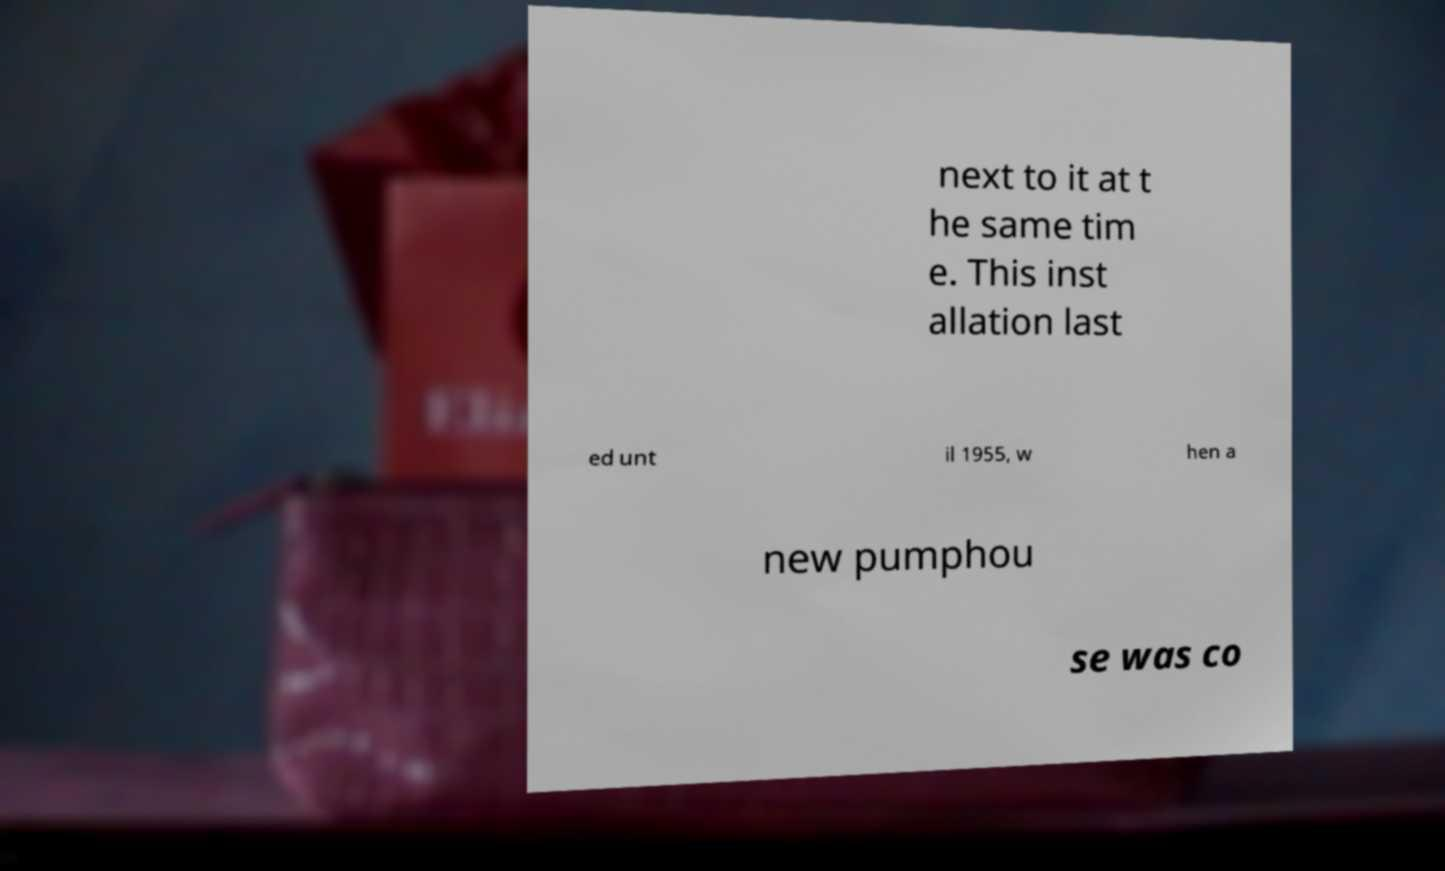Can you read and provide the text displayed in the image?This photo seems to have some interesting text. Can you extract and type it out for me? next to it at t he same tim e. This inst allation last ed unt il 1955, w hen a new pumphou se was co 